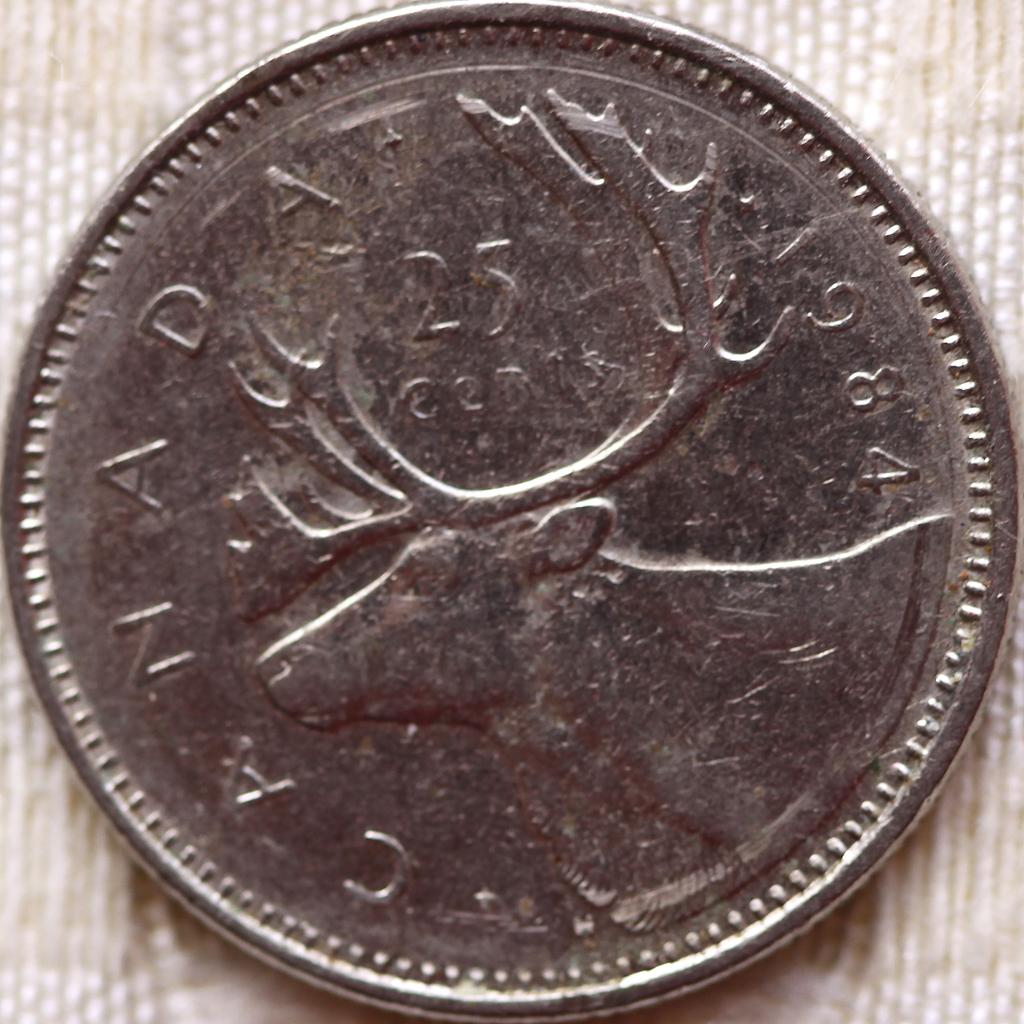What country is this coin from?
Make the answer very short. Canada. What country is this from?
Ensure brevity in your answer.  Canada. 